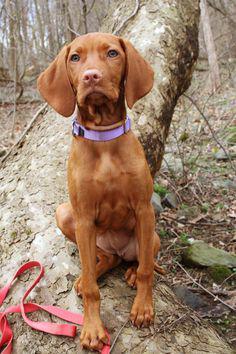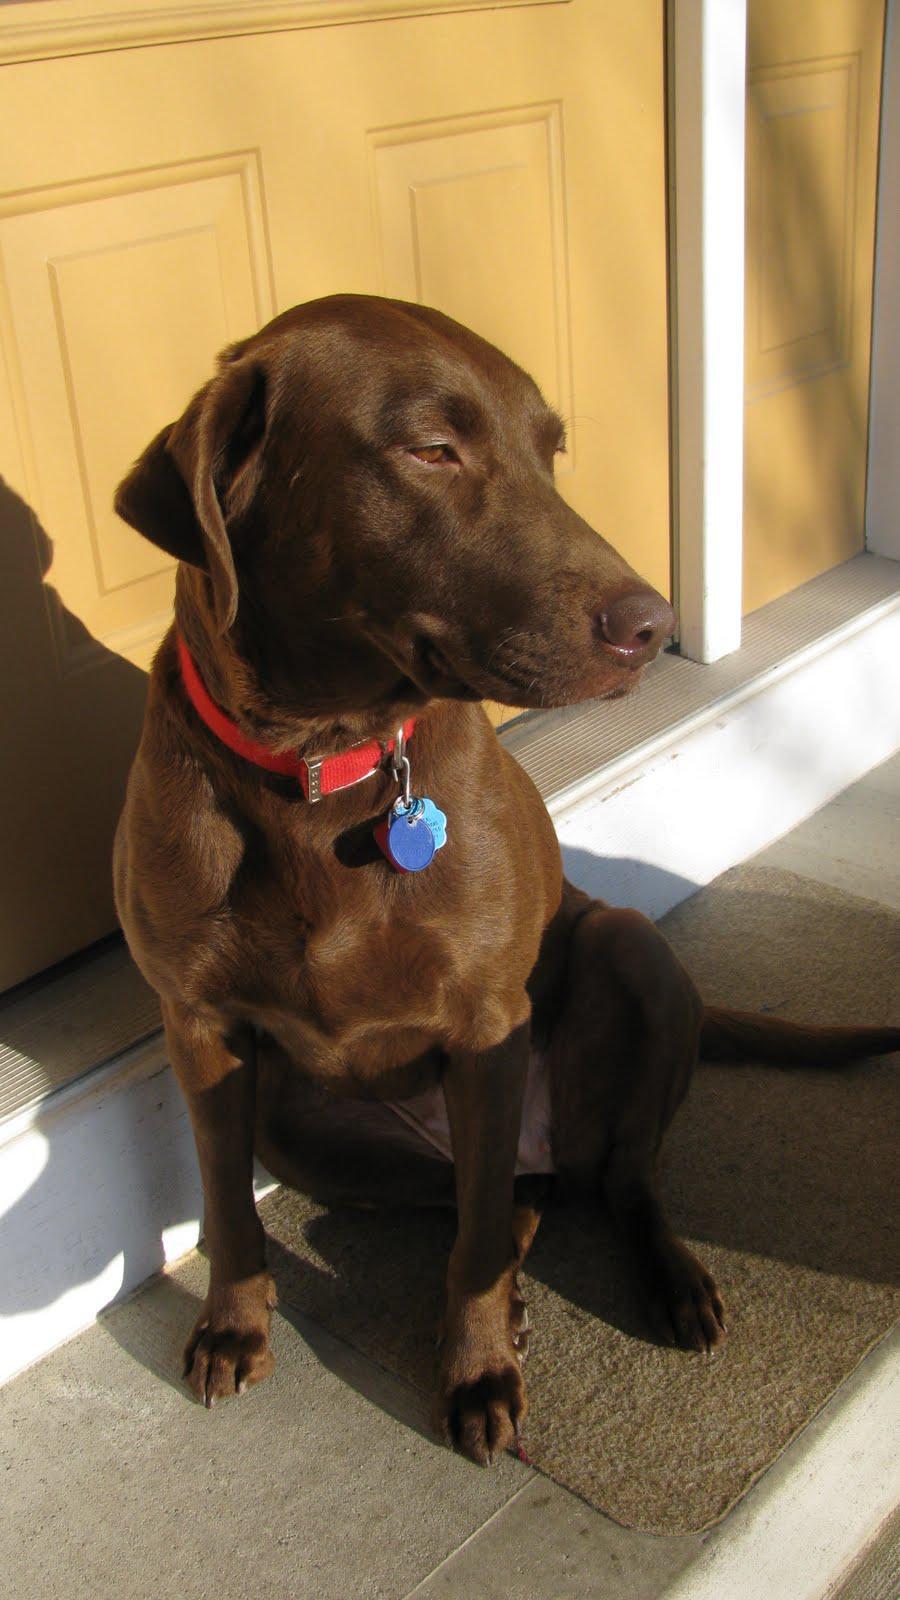The first image is the image on the left, the second image is the image on the right. Analyze the images presented: Is the assertion "A dog in one of the images is sitting on a wooden floor." valid? Answer yes or no. No. The first image is the image on the left, the second image is the image on the right. Assess this claim about the two images: "One brown dog is sitting upright on a wood floor, and the other brown dog is reclining with its body in profile but its head turned to the camera.". Correct or not? Answer yes or no. No. 